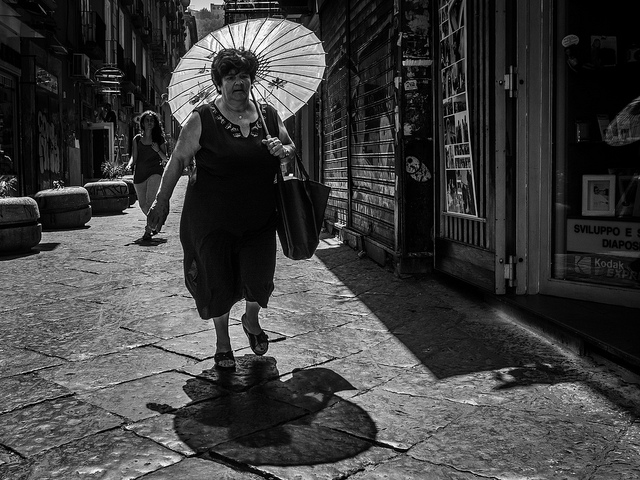<image>What year was this picture taken? I don't know what year this picture was taken. It could be 1990, 2015, 2014, 1910, 1995, 2000, or 1977. What year was this picture taken? I don't know what year the picture was taken. It can be seen in various years like 1990, 2015, 2014, 1910, 1995, 2000, and 1977. 